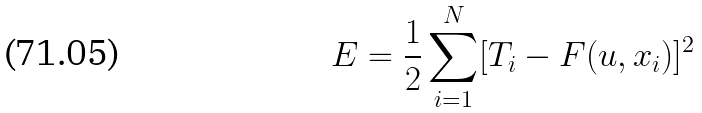<formula> <loc_0><loc_0><loc_500><loc_500>E = \frac { 1 } { 2 } \sum _ { i = 1 } ^ { N } [ T _ { i } - F ( { u } , x _ { i } ) ] ^ { 2 }</formula> 